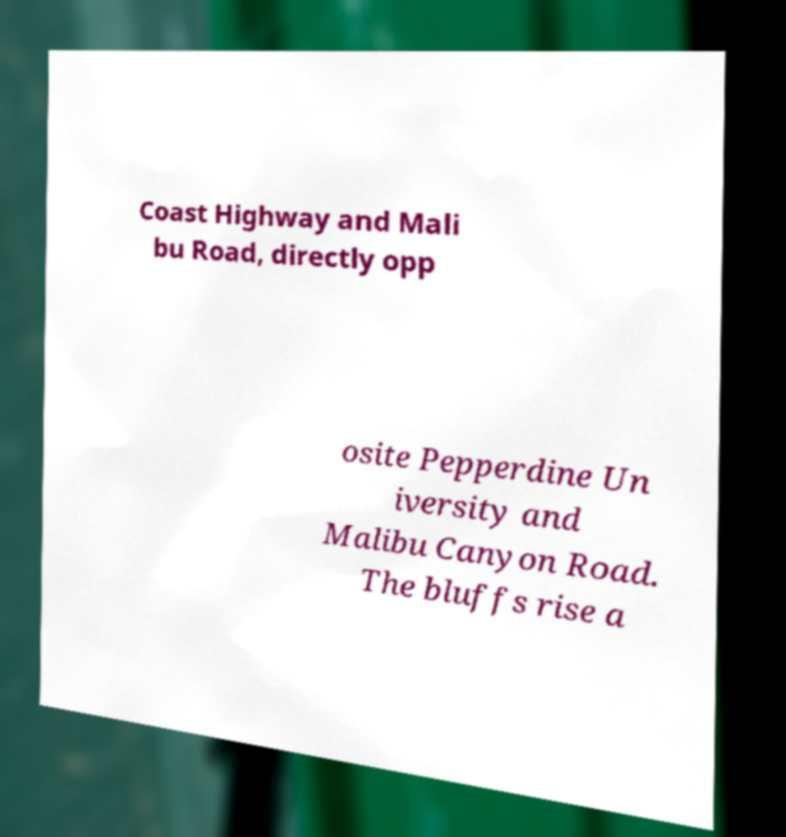Please read and relay the text visible in this image. What does it say? Coast Highway and Mali bu Road, directly opp osite Pepperdine Un iversity and Malibu Canyon Road. The bluffs rise a 